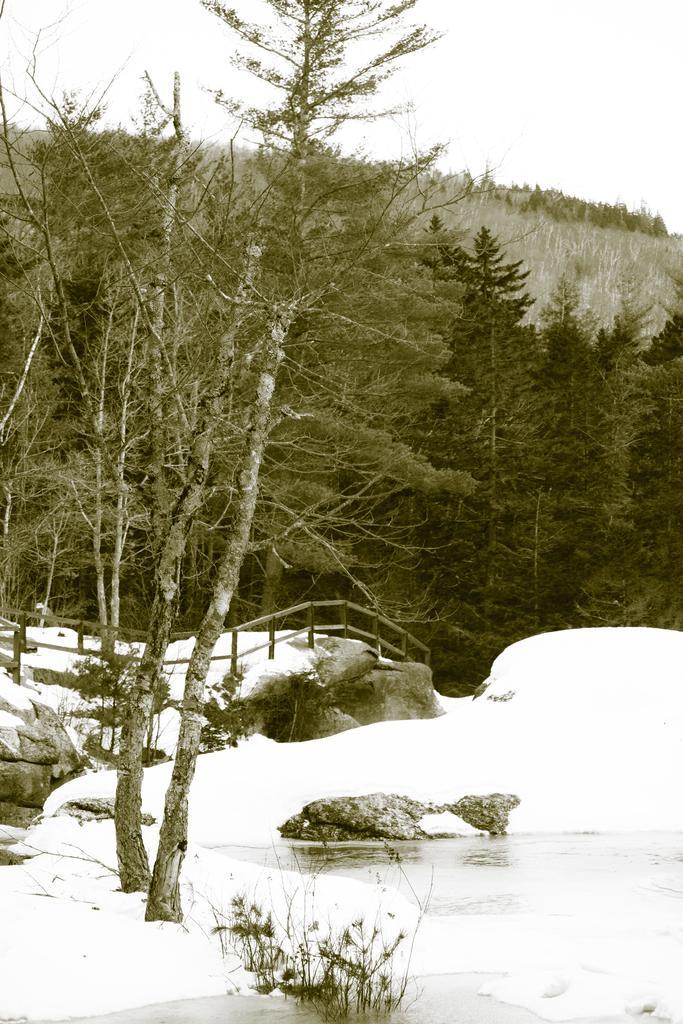Describe this image in one or two sentences. In this picture I can see trees and I can see water and snow and It looks like a foot over bridge and I can see a cloudy sky. 